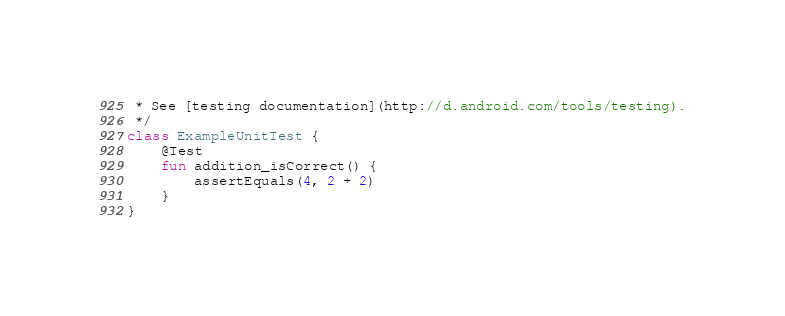<code> <loc_0><loc_0><loc_500><loc_500><_Kotlin_> * See [testing documentation](http://d.android.com/tools/testing).
 */
class ExampleUnitTest {
    @Test
    fun addition_isCorrect() {
        assertEquals(4, 2 + 2)
    }
}</code> 